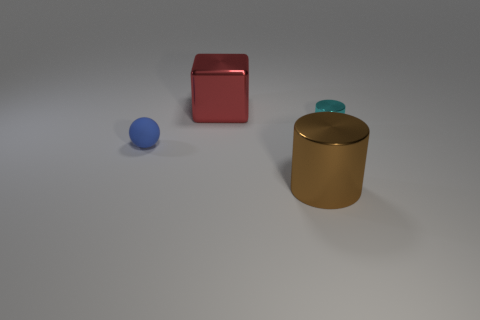Subtract 1 balls. How many balls are left? 0 Subtract all gray spheres. Subtract all red cubes. How many spheres are left? 1 Subtract all cyan cylinders. How many yellow blocks are left? 0 Subtract all tiny balls. Subtract all blue matte objects. How many objects are left? 2 Add 4 big red shiny things. How many big red shiny things are left? 5 Add 2 tiny yellow metallic cubes. How many tiny yellow metallic cubes exist? 2 Add 2 large red blocks. How many objects exist? 6 Subtract 0 brown balls. How many objects are left? 4 Subtract all spheres. How many objects are left? 3 